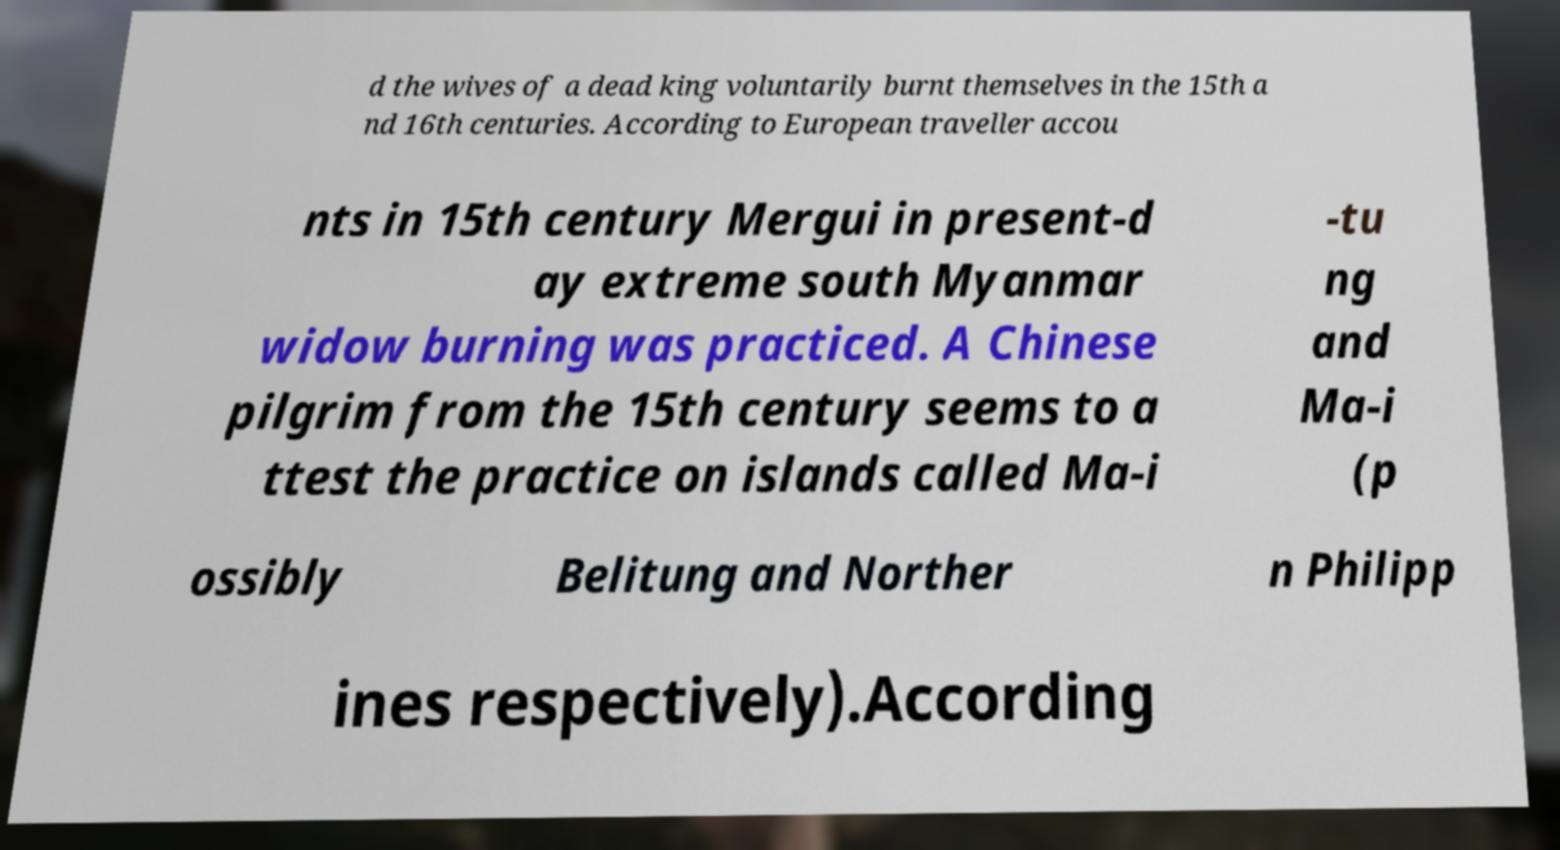What messages or text are displayed in this image? I need them in a readable, typed format. d the wives of a dead king voluntarily burnt themselves in the 15th a nd 16th centuries. According to European traveller accou nts in 15th century Mergui in present-d ay extreme south Myanmar widow burning was practiced. A Chinese pilgrim from the 15th century seems to a ttest the practice on islands called Ma-i -tu ng and Ma-i (p ossibly Belitung and Norther n Philipp ines respectively).According 